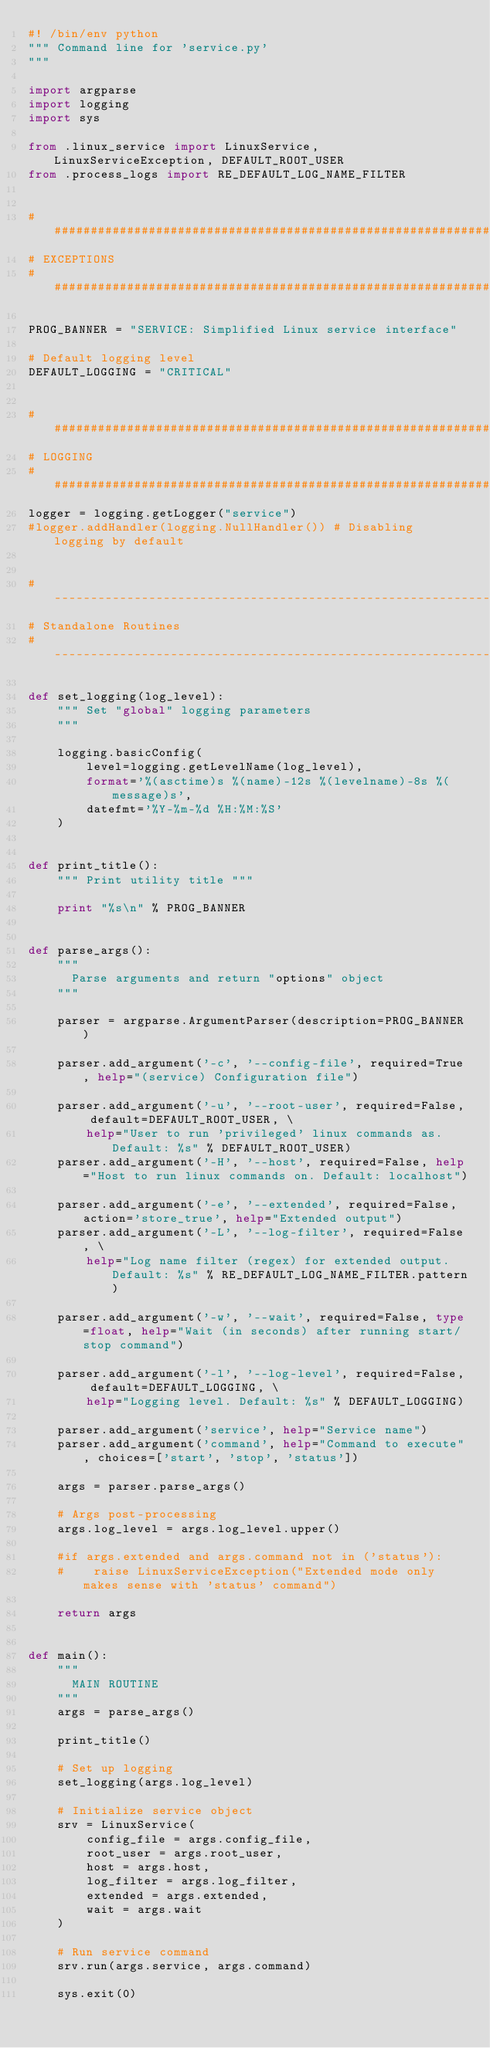Convert code to text. <code><loc_0><loc_0><loc_500><loc_500><_Python_>#! /bin/env python
""" Command line for 'service.py'
"""

import argparse
import logging
import sys

from .linux_service import LinuxService, LinuxServiceException, DEFAULT_ROOT_USER
from .process_logs import RE_DEFAULT_LOG_NAME_FILTER


###############################################################################
# EXCEPTIONS
###############################################################################

PROG_BANNER = "SERVICE: Simplified Linux service interface"

# Default logging level
DEFAULT_LOGGING = "CRITICAL"


###############################################################################
# LOGGING
###############################################################################
logger = logging.getLogger("service")
#logger.addHandler(logging.NullHandler()) # Disabling logging by default


# -----------------------------------------------------------------------
# Standalone Routines
# -----------------------------------------------------------------------

def set_logging(log_level):
    """ Set "global" logging parameters
    """

    logging.basicConfig(
        level=logging.getLevelName(log_level),
        format='%(asctime)s %(name)-12s %(levelname)-8s %(message)s',
        datefmt='%Y-%m-%d %H:%M:%S'
    )


def print_title():
    """ Print utility title """

    print "%s\n" % PROG_BANNER


def parse_args():
    """
      Parse arguments and return "options" object
    """

    parser = argparse.ArgumentParser(description=PROG_BANNER)

    parser.add_argument('-c', '--config-file', required=True, help="(service) Configuration file")

    parser.add_argument('-u', '--root-user', required=False, default=DEFAULT_ROOT_USER, \
        help="User to run 'privileged' linux commands as. Default: %s" % DEFAULT_ROOT_USER)
    parser.add_argument('-H', '--host', required=False, help="Host to run linux commands on. Default: localhost")

    parser.add_argument('-e', '--extended', required=False, action='store_true', help="Extended output")
    parser.add_argument('-L', '--log-filter', required=False, \
        help="Log name filter (regex) for extended output. Default: %s" % RE_DEFAULT_LOG_NAME_FILTER.pattern)

    parser.add_argument('-w', '--wait', required=False, type=float, help="Wait (in seconds) after running start/stop command")

    parser.add_argument('-l', '--log-level', required=False, default=DEFAULT_LOGGING, \
        help="Logging level. Default: %s" % DEFAULT_LOGGING)

    parser.add_argument('service', help="Service name")
    parser.add_argument('command', help="Command to execute", choices=['start', 'stop', 'status'])

    args = parser.parse_args()

    # Args post-processing
    args.log_level = args.log_level.upper()

    #if args.extended and args.command not in ('status'):
    #    raise LinuxServiceException("Extended mode only makes sense with 'status' command")

    return args


def main():
    """
      MAIN ROUTINE
    """
    args = parse_args()

    print_title()

    # Set up logging
    set_logging(args.log_level)

    # Initialize service object
    srv = LinuxService(
        config_file = args.config_file,
        root_user = args.root_user,
        host = args.host,
        log_filter = args.log_filter,
        extended = args.extended,
        wait = args.wait
    )

    # Run service command
    srv.run(args.service, args.command)

    sys.exit(0)
</code> 